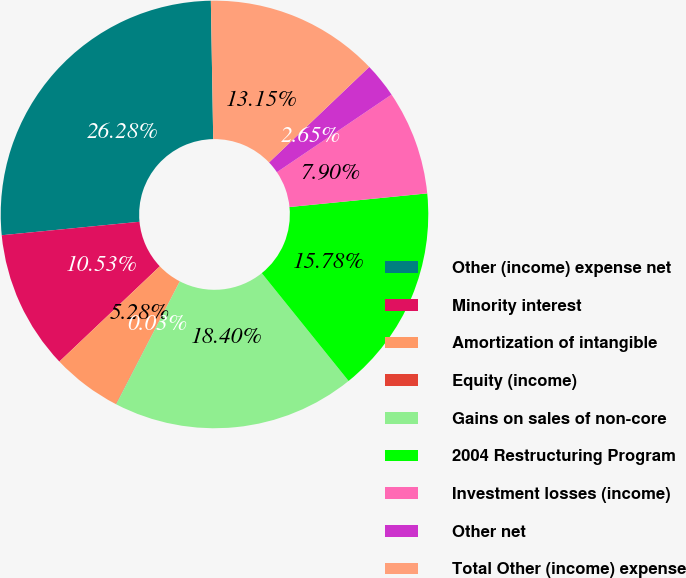<chart> <loc_0><loc_0><loc_500><loc_500><pie_chart><fcel>Other (income) expense net<fcel>Minority interest<fcel>Amortization of intangible<fcel>Equity (income)<fcel>Gains on sales of non-core<fcel>2004 Restructuring Program<fcel>Investment losses (income)<fcel>Other net<fcel>Total Other (income) expense<nl><fcel>26.28%<fcel>10.53%<fcel>5.28%<fcel>0.03%<fcel>18.4%<fcel>15.78%<fcel>7.9%<fcel>2.65%<fcel>13.15%<nl></chart> 